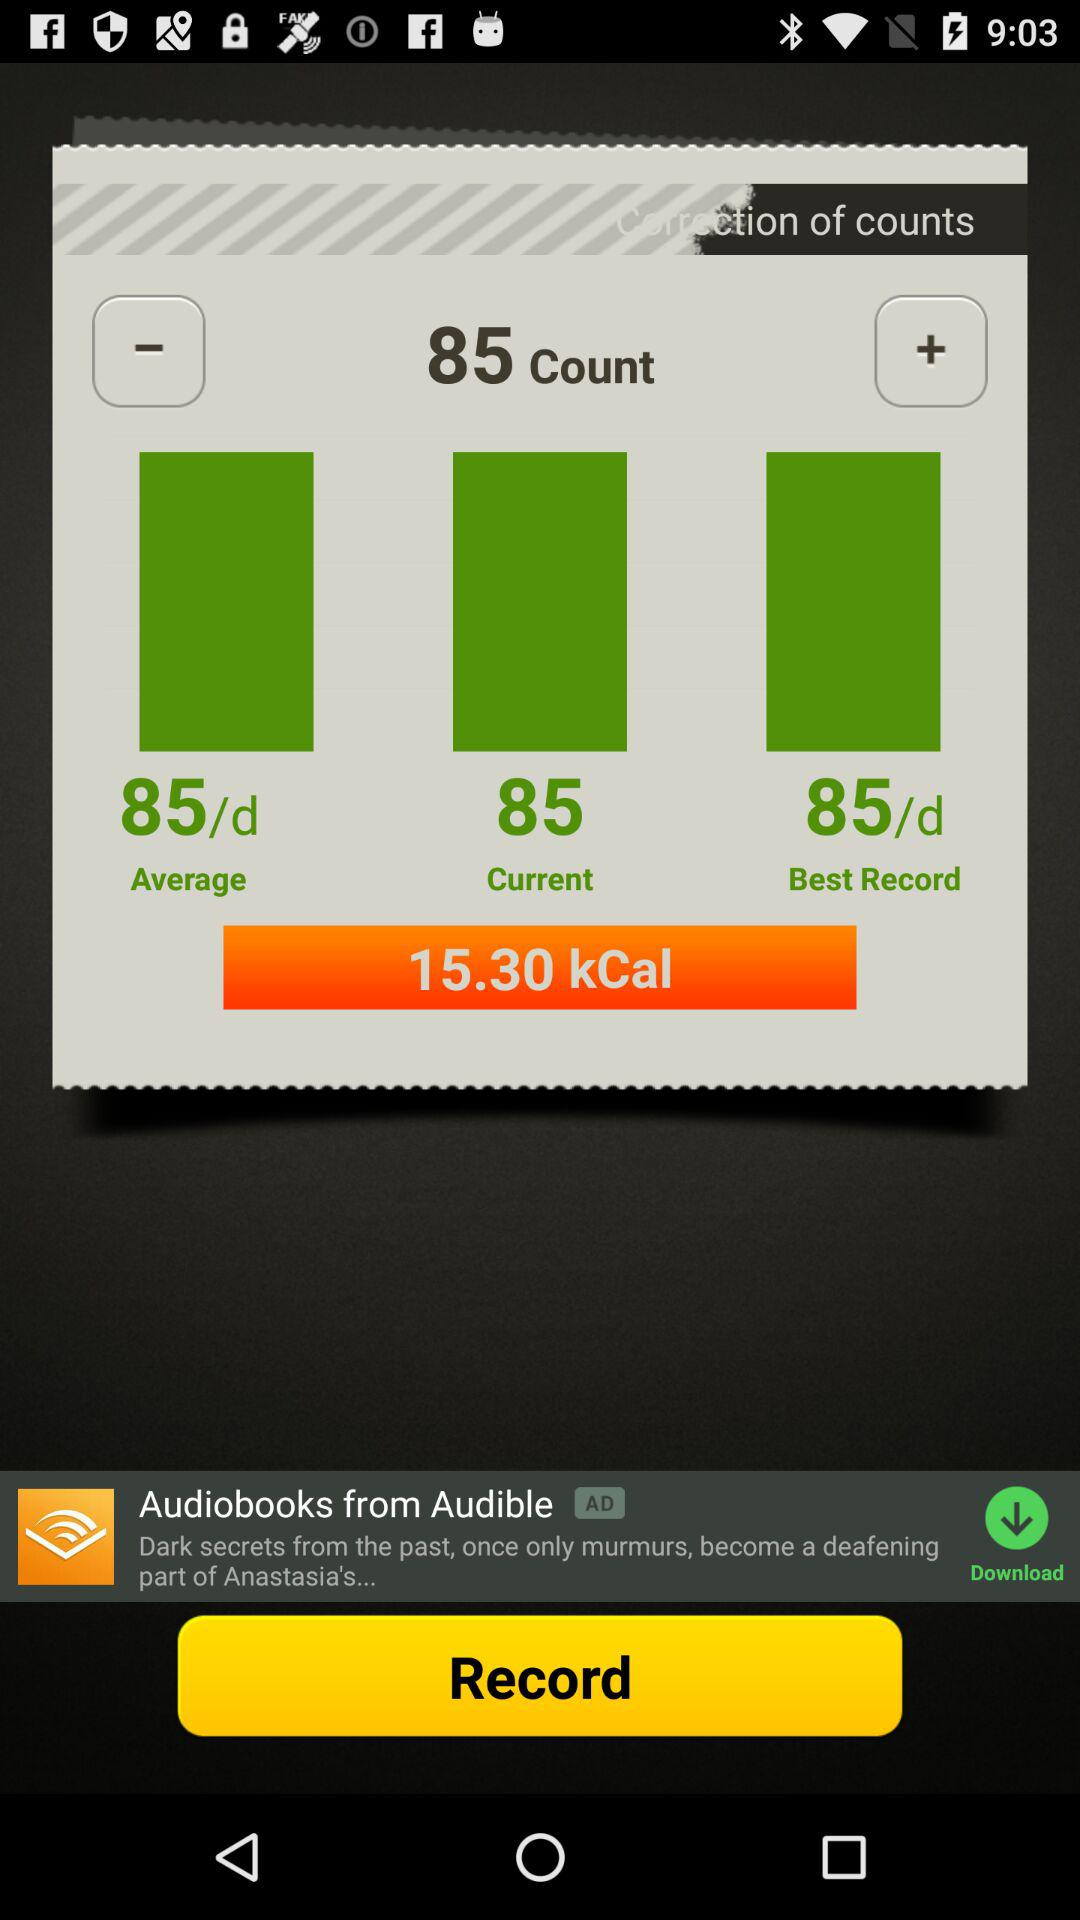What is the current count? The current count is 85. 